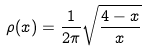<formula> <loc_0><loc_0><loc_500><loc_500>\rho ( x ) = \frac { 1 } { 2 \pi } \sqrt { \frac { 4 - x } { x } }</formula> 